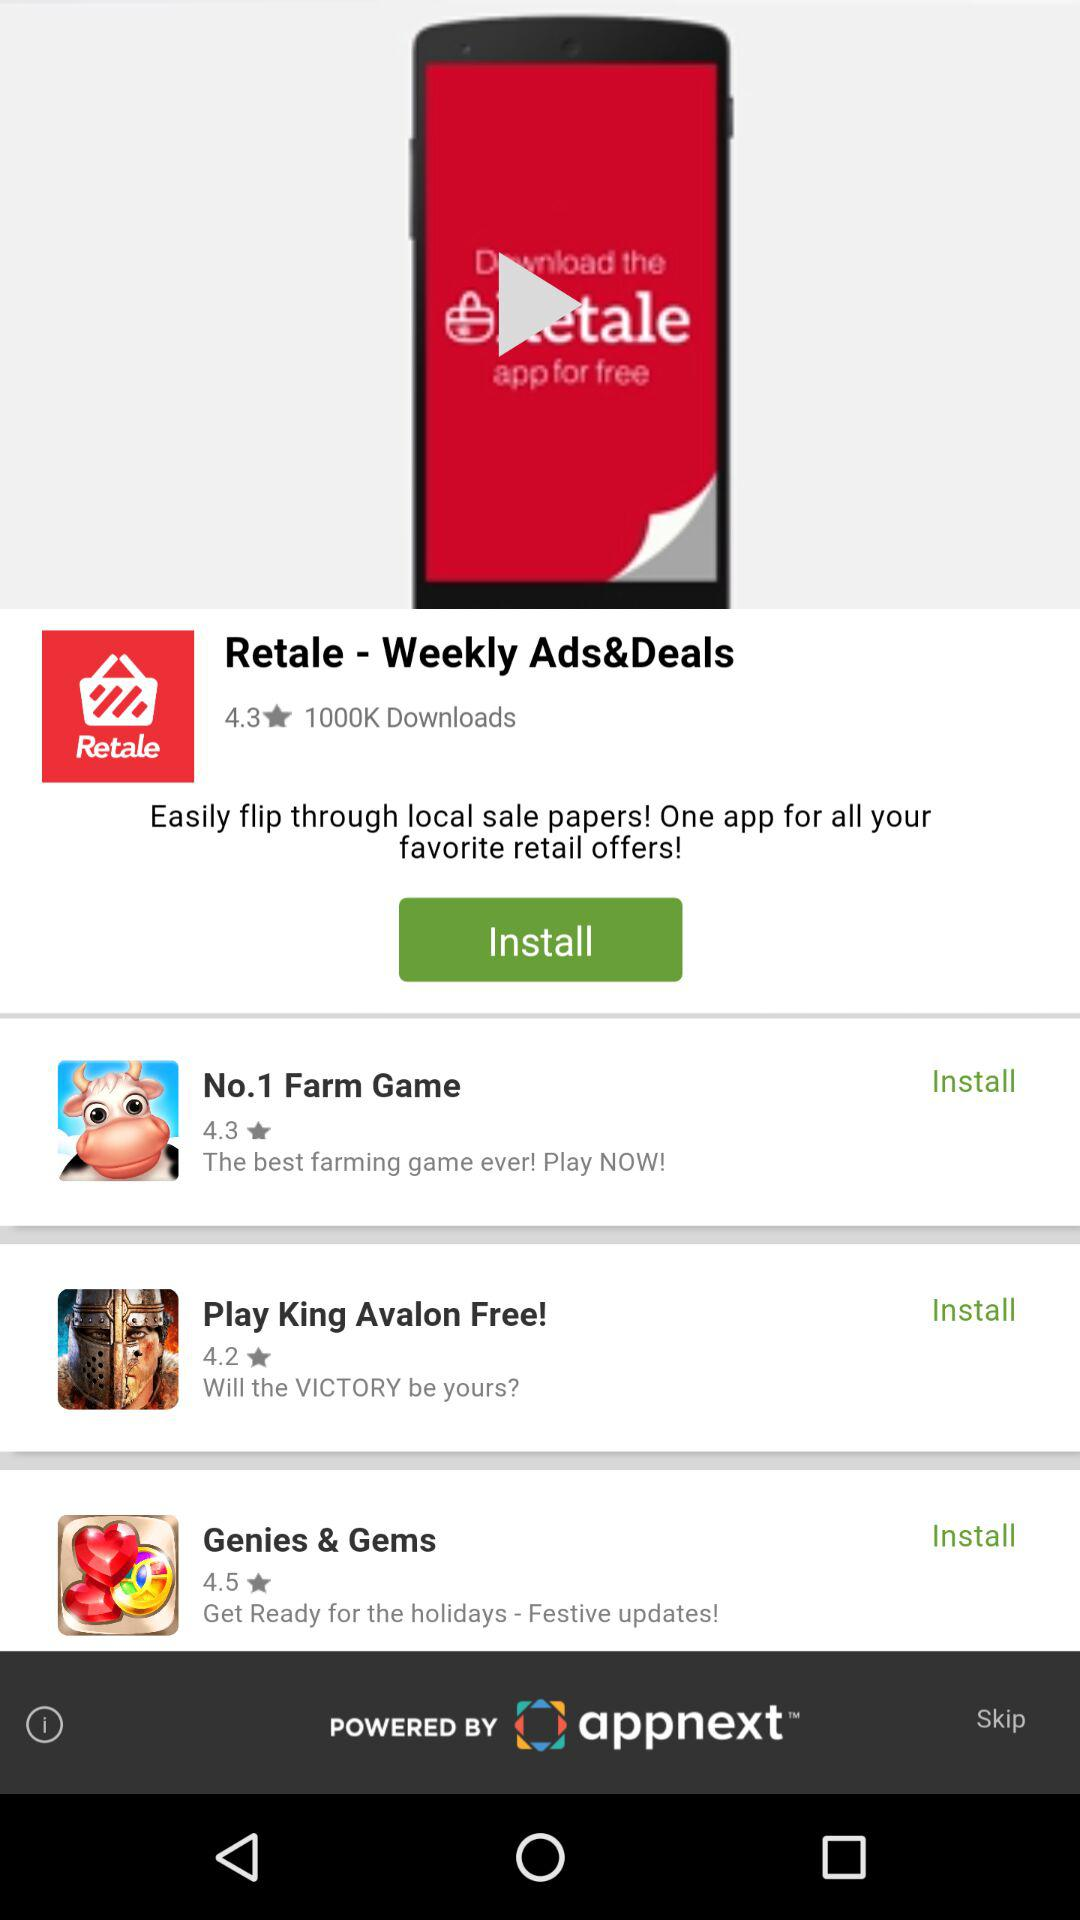How many apps have a rating of 4.3 or higher?
Answer the question using a single word or phrase. 3 